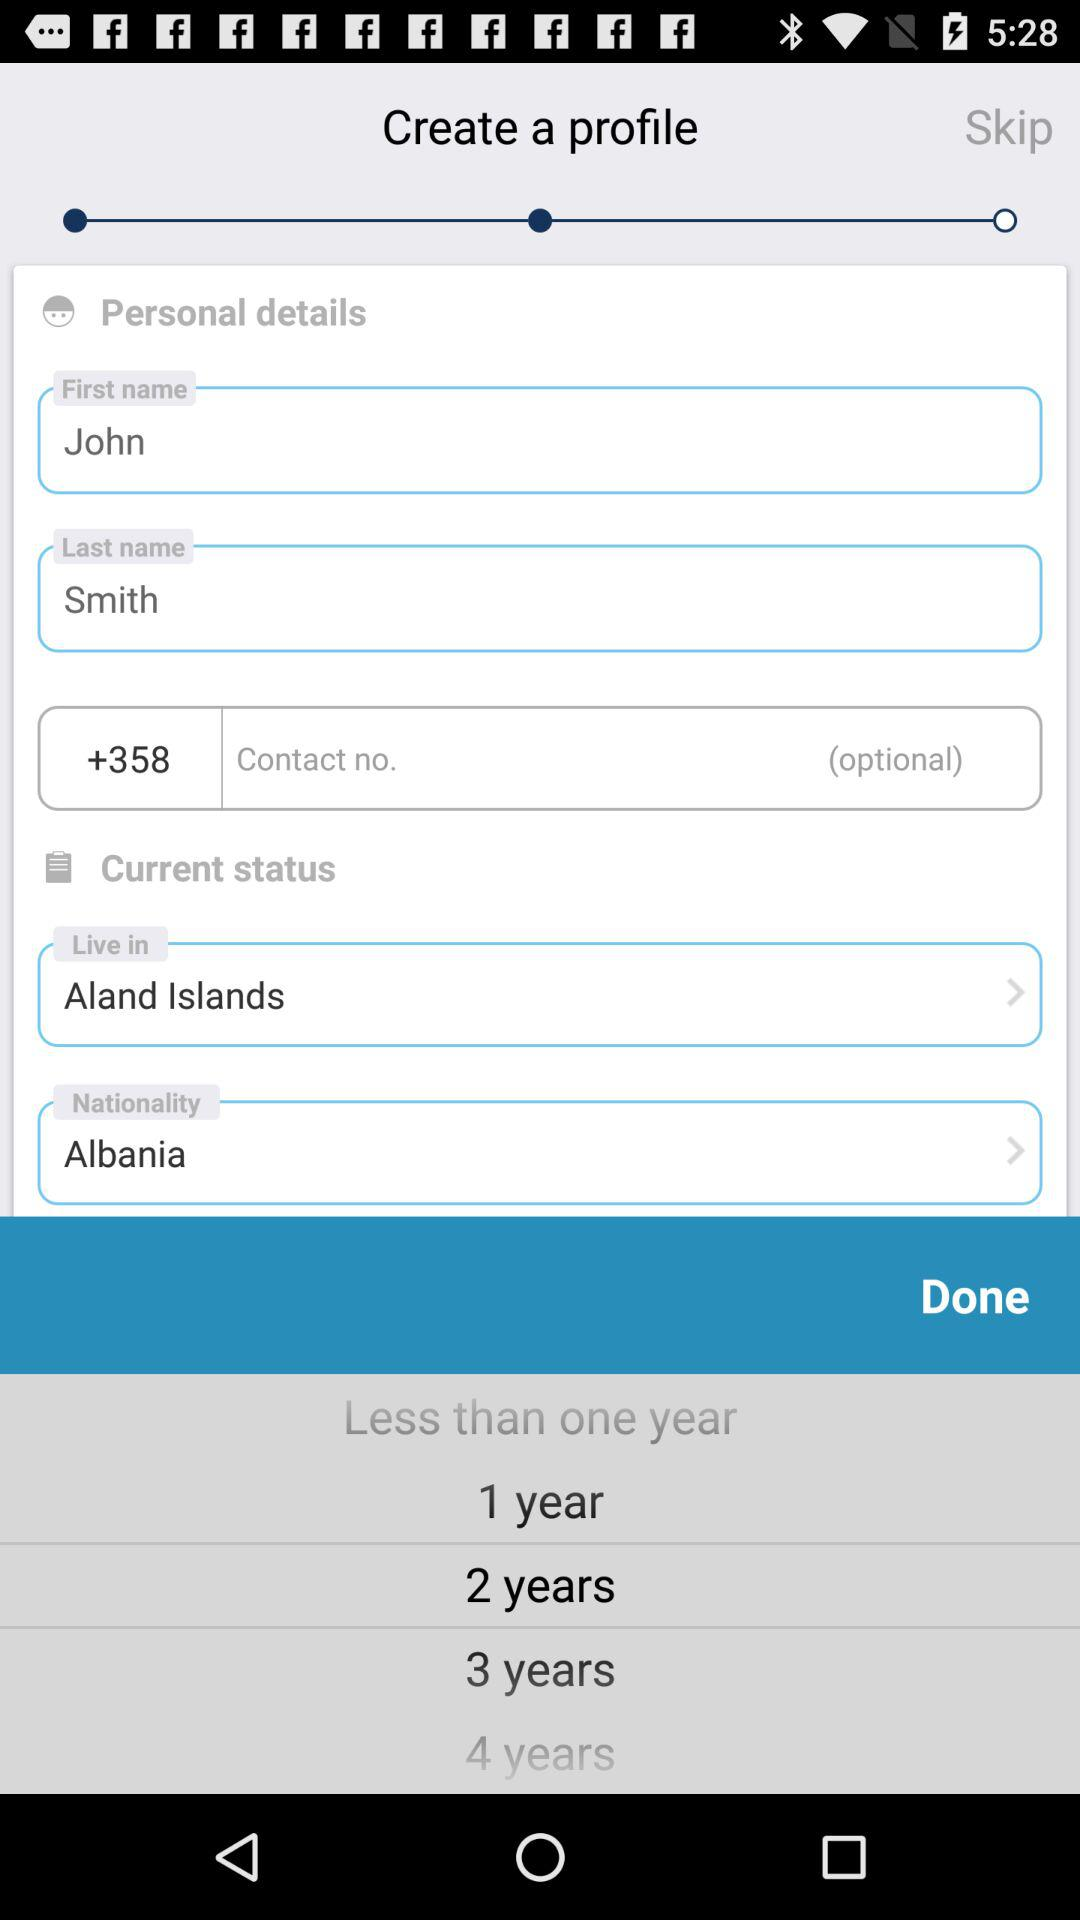Is the contact number optional or not? The contact number is optional. 